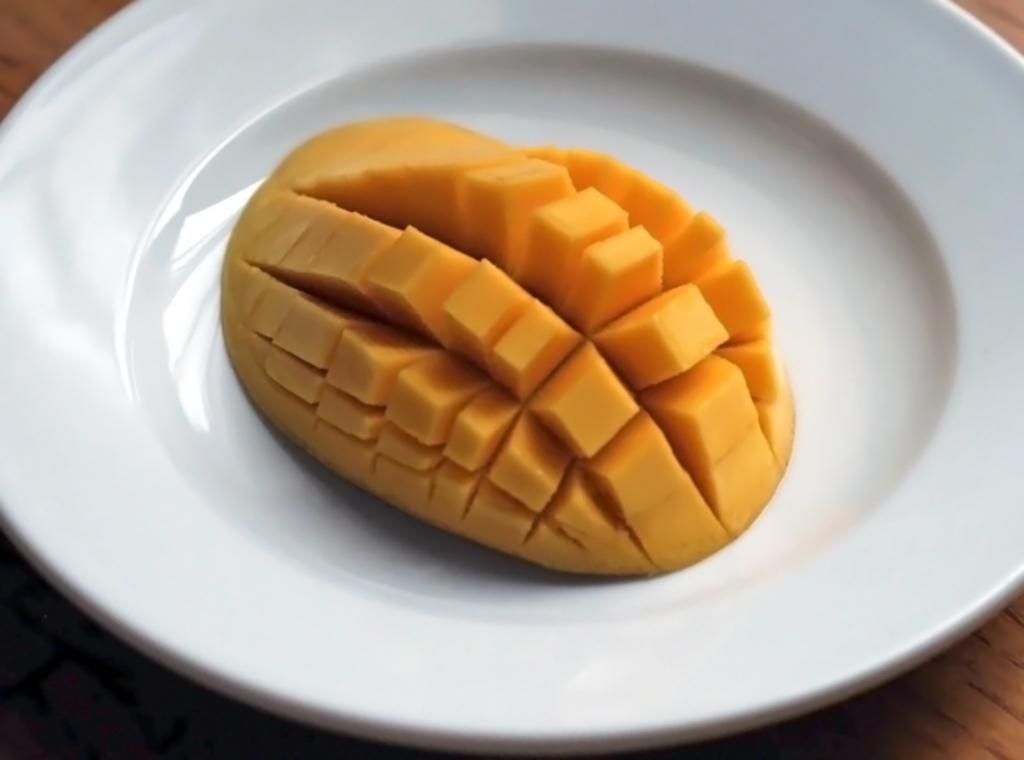What is on the plate that is visible in the image? The plate contains mangoes. Where is the plate located in the image? The plate is placed on a table. What type of government is depicted in the image? There is no depiction of a government in the image; it features a plate with mangoes on a table. What color is the death in the image? There is no death present in the image, and therefore no color can be assigned to it. 